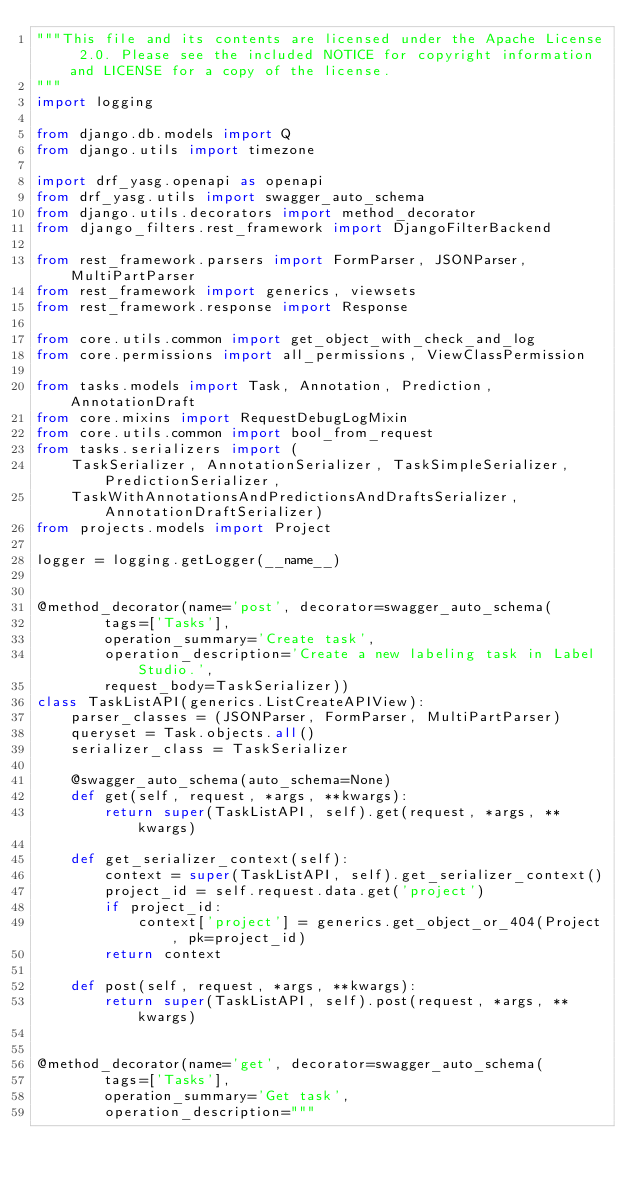Convert code to text. <code><loc_0><loc_0><loc_500><loc_500><_Python_>"""This file and its contents are licensed under the Apache License 2.0. Please see the included NOTICE for copyright information and LICENSE for a copy of the license.
"""
import logging

from django.db.models import Q
from django.utils import timezone

import drf_yasg.openapi as openapi
from drf_yasg.utils import swagger_auto_schema
from django.utils.decorators import method_decorator
from django_filters.rest_framework import DjangoFilterBackend

from rest_framework.parsers import FormParser, JSONParser, MultiPartParser
from rest_framework import generics, viewsets
from rest_framework.response import Response

from core.utils.common import get_object_with_check_and_log
from core.permissions import all_permissions, ViewClassPermission

from tasks.models import Task, Annotation, Prediction, AnnotationDraft
from core.mixins import RequestDebugLogMixin
from core.utils.common import bool_from_request
from tasks.serializers import (
    TaskSerializer, AnnotationSerializer, TaskSimpleSerializer, PredictionSerializer,
    TaskWithAnnotationsAndPredictionsAndDraftsSerializer, AnnotationDraftSerializer)
from projects.models import Project

logger = logging.getLogger(__name__)


@method_decorator(name='post', decorator=swagger_auto_schema(
        tags=['Tasks'],
        operation_summary='Create task',
        operation_description='Create a new labeling task in Label Studio.',
        request_body=TaskSerializer))
class TaskListAPI(generics.ListCreateAPIView):
    parser_classes = (JSONParser, FormParser, MultiPartParser)
    queryset = Task.objects.all()
    serializer_class = TaskSerializer

    @swagger_auto_schema(auto_schema=None)
    def get(self, request, *args, **kwargs):
        return super(TaskListAPI, self).get(request, *args, **kwargs)

    def get_serializer_context(self):
        context = super(TaskListAPI, self).get_serializer_context()
        project_id = self.request.data.get('project')
        if project_id:
            context['project'] = generics.get_object_or_404(Project, pk=project_id)
        return context

    def post(self, request, *args, **kwargs):
        return super(TaskListAPI, self).post(request, *args, **kwargs)


@method_decorator(name='get', decorator=swagger_auto_schema(
        tags=['Tasks'],
        operation_summary='Get task',
        operation_description="""</code> 